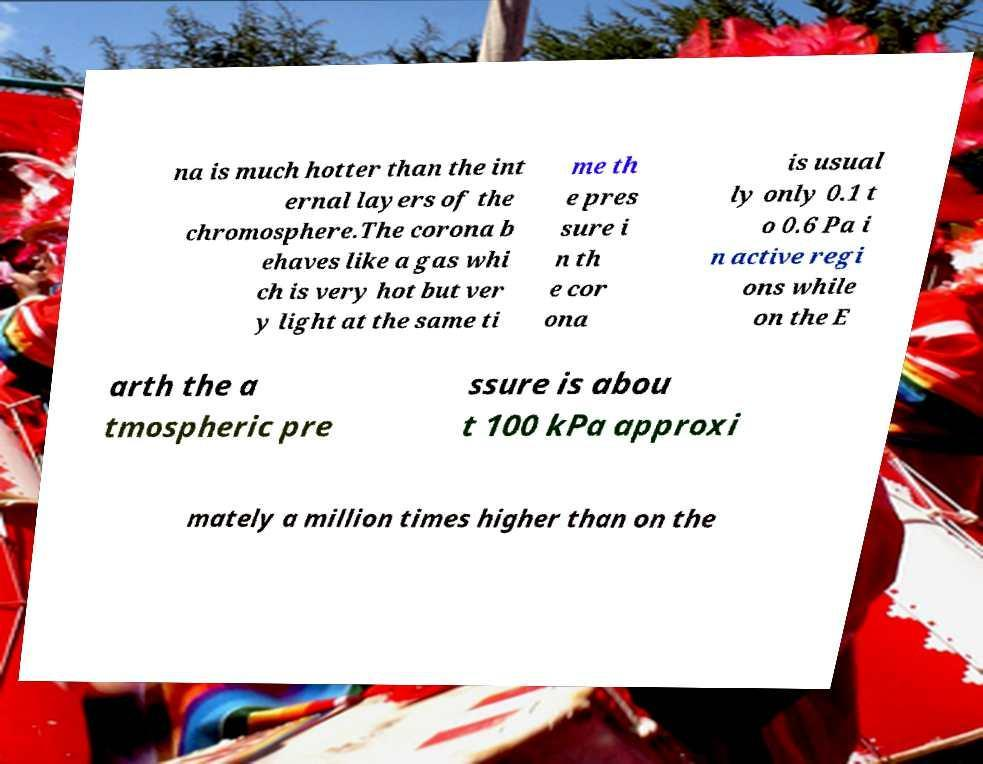Can you read and provide the text displayed in the image?This photo seems to have some interesting text. Can you extract and type it out for me? na is much hotter than the int ernal layers of the chromosphere.The corona b ehaves like a gas whi ch is very hot but ver y light at the same ti me th e pres sure i n th e cor ona is usual ly only 0.1 t o 0.6 Pa i n active regi ons while on the E arth the a tmospheric pre ssure is abou t 100 kPa approxi mately a million times higher than on the 